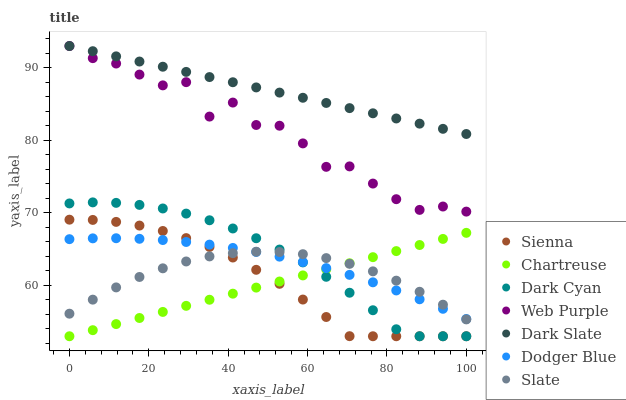Does Chartreuse have the minimum area under the curve?
Answer yes or no. Yes. Does Dark Slate have the maximum area under the curve?
Answer yes or no. Yes. Does Web Purple have the minimum area under the curve?
Answer yes or no. No. Does Web Purple have the maximum area under the curve?
Answer yes or no. No. Is Chartreuse the smoothest?
Answer yes or no. Yes. Is Web Purple the roughest?
Answer yes or no. Yes. Is Sienna the smoothest?
Answer yes or no. No. Is Sienna the roughest?
Answer yes or no. No. Does Sienna have the lowest value?
Answer yes or no. Yes. Does Web Purple have the lowest value?
Answer yes or no. No. Does Dark Slate have the highest value?
Answer yes or no. Yes. Does Sienna have the highest value?
Answer yes or no. No. Is Dark Cyan less than Web Purple?
Answer yes or no. Yes. Is Dark Slate greater than Chartreuse?
Answer yes or no. Yes. Does Dark Cyan intersect Dodger Blue?
Answer yes or no. Yes. Is Dark Cyan less than Dodger Blue?
Answer yes or no. No. Is Dark Cyan greater than Dodger Blue?
Answer yes or no. No. Does Dark Cyan intersect Web Purple?
Answer yes or no. No. 